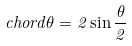Convert formula to latex. <formula><loc_0><loc_0><loc_500><loc_500>c h o r d \theta = 2 \sin \frac { \theta } { 2 }</formula> 